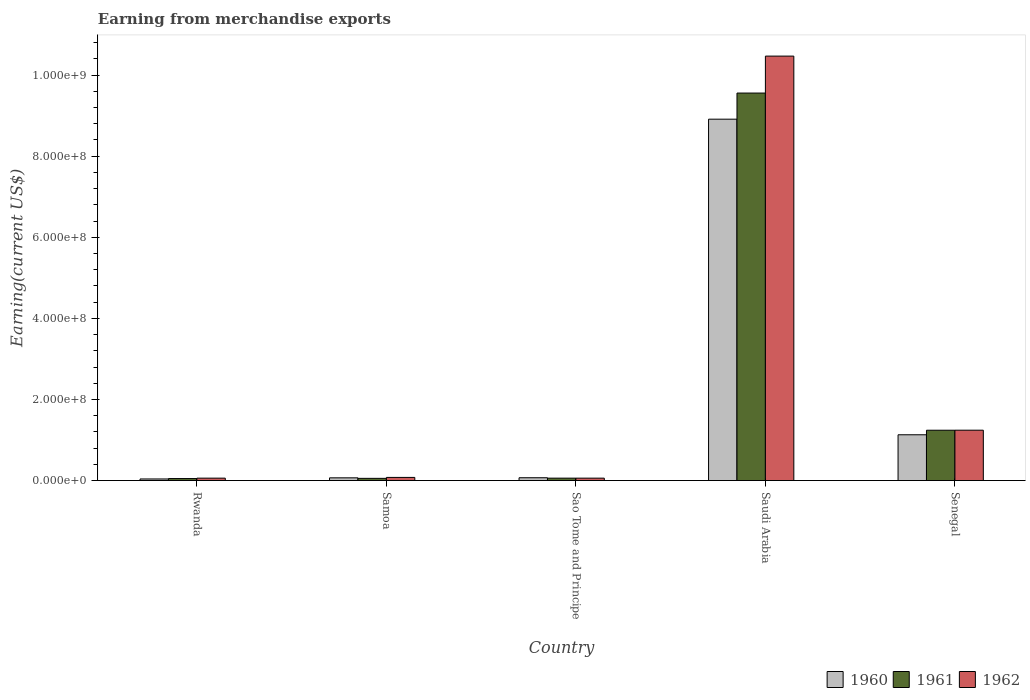How many groups of bars are there?
Ensure brevity in your answer.  5. Are the number of bars on each tick of the X-axis equal?
Provide a succinct answer. Yes. What is the label of the 2nd group of bars from the left?
Provide a succinct answer. Samoa. In how many cases, is the number of bars for a given country not equal to the number of legend labels?
Your answer should be very brief. 0. Across all countries, what is the maximum amount earned from merchandise exports in 1961?
Provide a short and direct response. 9.56e+08. Across all countries, what is the minimum amount earned from merchandise exports in 1960?
Provide a short and direct response. 4.00e+06. In which country was the amount earned from merchandise exports in 1962 maximum?
Keep it short and to the point. Saudi Arabia. In which country was the amount earned from merchandise exports in 1961 minimum?
Give a very brief answer. Rwanda. What is the total amount earned from merchandise exports in 1962 in the graph?
Make the answer very short. 1.19e+09. What is the difference between the amount earned from merchandise exports in 1960 in Rwanda and that in Sao Tome and Principe?
Your response must be concise. -3.00e+06. What is the average amount earned from merchandise exports in 1960 per country?
Keep it short and to the point. 2.04e+08. What is the difference between the amount earned from merchandise exports of/in 1960 and amount earned from merchandise exports of/in 1961 in Senegal?
Offer a very short reply. -1.12e+07. In how many countries, is the amount earned from merchandise exports in 1960 greater than 80000000 US$?
Provide a succinct answer. 2. What is the ratio of the amount earned from merchandise exports in 1962 in Rwanda to that in Saudi Arabia?
Give a very brief answer. 0.01. What is the difference between the highest and the second highest amount earned from merchandise exports in 1962?
Your answer should be compact. 1.04e+09. What is the difference between the highest and the lowest amount earned from merchandise exports in 1960?
Your answer should be compact. 8.87e+08. Is the sum of the amount earned from merchandise exports in 1960 in Rwanda and Sao Tome and Principe greater than the maximum amount earned from merchandise exports in 1962 across all countries?
Make the answer very short. No. What does the 2nd bar from the left in Saudi Arabia represents?
Ensure brevity in your answer.  1961. What does the 1st bar from the right in Saudi Arabia represents?
Your answer should be very brief. 1962. Is it the case that in every country, the sum of the amount earned from merchandise exports in 1961 and amount earned from merchandise exports in 1960 is greater than the amount earned from merchandise exports in 1962?
Offer a very short reply. Yes. How many bars are there?
Ensure brevity in your answer.  15. How many countries are there in the graph?
Keep it short and to the point. 5. What is the difference between two consecutive major ticks on the Y-axis?
Offer a very short reply. 2.00e+08. Are the values on the major ticks of Y-axis written in scientific E-notation?
Provide a succinct answer. Yes. What is the title of the graph?
Offer a terse response. Earning from merchandise exports. What is the label or title of the X-axis?
Provide a short and direct response. Country. What is the label or title of the Y-axis?
Make the answer very short. Earning(current US$). What is the Earning(current US$) in 1960 in Rwanda?
Make the answer very short. 4.00e+06. What is the Earning(current US$) in 1961 in Rwanda?
Your answer should be compact. 5.00e+06. What is the Earning(current US$) in 1962 in Rwanda?
Your answer should be compact. 6.00e+06. What is the Earning(current US$) in 1960 in Samoa?
Give a very brief answer. 6.77e+06. What is the Earning(current US$) in 1961 in Samoa?
Provide a succinct answer. 5.49e+06. What is the Earning(current US$) in 1962 in Samoa?
Make the answer very short. 7.80e+06. What is the Earning(current US$) of 1960 in Sao Tome and Principe?
Offer a terse response. 7.00e+06. What is the Earning(current US$) of 1962 in Sao Tome and Principe?
Ensure brevity in your answer.  6.00e+06. What is the Earning(current US$) of 1960 in Saudi Arabia?
Your answer should be compact. 8.91e+08. What is the Earning(current US$) of 1961 in Saudi Arabia?
Offer a terse response. 9.56e+08. What is the Earning(current US$) of 1962 in Saudi Arabia?
Provide a short and direct response. 1.05e+09. What is the Earning(current US$) in 1960 in Senegal?
Your answer should be compact. 1.13e+08. What is the Earning(current US$) of 1961 in Senegal?
Offer a terse response. 1.24e+08. What is the Earning(current US$) in 1962 in Senegal?
Make the answer very short. 1.24e+08. Across all countries, what is the maximum Earning(current US$) in 1960?
Your response must be concise. 8.91e+08. Across all countries, what is the maximum Earning(current US$) in 1961?
Offer a terse response. 9.56e+08. Across all countries, what is the maximum Earning(current US$) of 1962?
Your answer should be compact. 1.05e+09. What is the total Earning(current US$) in 1960 in the graph?
Offer a terse response. 1.02e+09. What is the total Earning(current US$) in 1961 in the graph?
Make the answer very short. 1.10e+09. What is the total Earning(current US$) of 1962 in the graph?
Your answer should be very brief. 1.19e+09. What is the difference between the Earning(current US$) of 1960 in Rwanda and that in Samoa?
Keep it short and to the point. -2.77e+06. What is the difference between the Earning(current US$) of 1961 in Rwanda and that in Samoa?
Offer a terse response. -4.86e+05. What is the difference between the Earning(current US$) in 1962 in Rwanda and that in Samoa?
Your answer should be very brief. -1.80e+06. What is the difference between the Earning(current US$) of 1960 in Rwanda and that in Sao Tome and Principe?
Make the answer very short. -3.00e+06. What is the difference between the Earning(current US$) in 1961 in Rwanda and that in Sao Tome and Principe?
Provide a short and direct response. -1.00e+06. What is the difference between the Earning(current US$) in 1960 in Rwanda and that in Saudi Arabia?
Your answer should be compact. -8.87e+08. What is the difference between the Earning(current US$) of 1961 in Rwanda and that in Saudi Arabia?
Give a very brief answer. -9.51e+08. What is the difference between the Earning(current US$) of 1962 in Rwanda and that in Saudi Arabia?
Ensure brevity in your answer.  -1.04e+09. What is the difference between the Earning(current US$) of 1960 in Rwanda and that in Senegal?
Keep it short and to the point. -1.09e+08. What is the difference between the Earning(current US$) of 1961 in Rwanda and that in Senegal?
Offer a terse response. -1.19e+08. What is the difference between the Earning(current US$) in 1962 in Rwanda and that in Senegal?
Offer a terse response. -1.18e+08. What is the difference between the Earning(current US$) of 1960 in Samoa and that in Sao Tome and Principe?
Ensure brevity in your answer.  -2.32e+05. What is the difference between the Earning(current US$) in 1961 in Samoa and that in Sao Tome and Principe?
Provide a succinct answer. -5.14e+05. What is the difference between the Earning(current US$) of 1962 in Samoa and that in Sao Tome and Principe?
Your answer should be very brief. 1.80e+06. What is the difference between the Earning(current US$) of 1960 in Samoa and that in Saudi Arabia?
Ensure brevity in your answer.  -8.84e+08. What is the difference between the Earning(current US$) in 1961 in Samoa and that in Saudi Arabia?
Give a very brief answer. -9.50e+08. What is the difference between the Earning(current US$) of 1962 in Samoa and that in Saudi Arabia?
Your answer should be very brief. -1.04e+09. What is the difference between the Earning(current US$) in 1960 in Samoa and that in Senegal?
Your answer should be compact. -1.06e+08. What is the difference between the Earning(current US$) of 1961 in Samoa and that in Senegal?
Your answer should be compact. -1.19e+08. What is the difference between the Earning(current US$) in 1962 in Samoa and that in Senegal?
Give a very brief answer. -1.16e+08. What is the difference between the Earning(current US$) in 1960 in Sao Tome and Principe and that in Saudi Arabia?
Your answer should be very brief. -8.84e+08. What is the difference between the Earning(current US$) in 1961 in Sao Tome and Principe and that in Saudi Arabia?
Your response must be concise. -9.50e+08. What is the difference between the Earning(current US$) of 1962 in Sao Tome and Principe and that in Saudi Arabia?
Your response must be concise. -1.04e+09. What is the difference between the Earning(current US$) in 1960 in Sao Tome and Principe and that in Senegal?
Your response must be concise. -1.06e+08. What is the difference between the Earning(current US$) in 1961 in Sao Tome and Principe and that in Senegal?
Provide a short and direct response. -1.18e+08. What is the difference between the Earning(current US$) of 1962 in Sao Tome and Principe and that in Senegal?
Offer a terse response. -1.18e+08. What is the difference between the Earning(current US$) of 1960 in Saudi Arabia and that in Senegal?
Your answer should be very brief. 7.78e+08. What is the difference between the Earning(current US$) of 1961 in Saudi Arabia and that in Senegal?
Your answer should be very brief. 8.31e+08. What is the difference between the Earning(current US$) in 1962 in Saudi Arabia and that in Senegal?
Offer a terse response. 9.22e+08. What is the difference between the Earning(current US$) of 1960 in Rwanda and the Earning(current US$) of 1961 in Samoa?
Your response must be concise. -1.49e+06. What is the difference between the Earning(current US$) of 1960 in Rwanda and the Earning(current US$) of 1962 in Samoa?
Your answer should be compact. -3.80e+06. What is the difference between the Earning(current US$) in 1961 in Rwanda and the Earning(current US$) in 1962 in Samoa?
Ensure brevity in your answer.  -2.80e+06. What is the difference between the Earning(current US$) in 1960 in Rwanda and the Earning(current US$) in 1962 in Sao Tome and Principe?
Offer a very short reply. -2.00e+06. What is the difference between the Earning(current US$) of 1961 in Rwanda and the Earning(current US$) of 1962 in Sao Tome and Principe?
Your answer should be very brief. -1.00e+06. What is the difference between the Earning(current US$) in 1960 in Rwanda and the Earning(current US$) in 1961 in Saudi Arabia?
Offer a very short reply. -9.52e+08. What is the difference between the Earning(current US$) in 1960 in Rwanda and the Earning(current US$) in 1962 in Saudi Arabia?
Give a very brief answer. -1.04e+09. What is the difference between the Earning(current US$) of 1961 in Rwanda and the Earning(current US$) of 1962 in Saudi Arabia?
Provide a short and direct response. -1.04e+09. What is the difference between the Earning(current US$) of 1960 in Rwanda and the Earning(current US$) of 1961 in Senegal?
Keep it short and to the point. -1.20e+08. What is the difference between the Earning(current US$) in 1960 in Rwanda and the Earning(current US$) in 1962 in Senegal?
Keep it short and to the point. -1.20e+08. What is the difference between the Earning(current US$) of 1961 in Rwanda and the Earning(current US$) of 1962 in Senegal?
Make the answer very short. -1.19e+08. What is the difference between the Earning(current US$) in 1960 in Samoa and the Earning(current US$) in 1961 in Sao Tome and Principe?
Your response must be concise. 7.68e+05. What is the difference between the Earning(current US$) of 1960 in Samoa and the Earning(current US$) of 1962 in Sao Tome and Principe?
Ensure brevity in your answer.  7.68e+05. What is the difference between the Earning(current US$) in 1961 in Samoa and the Earning(current US$) in 1962 in Sao Tome and Principe?
Your response must be concise. -5.14e+05. What is the difference between the Earning(current US$) of 1960 in Samoa and the Earning(current US$) of 1961 in Saudi Arabia?
Keep it short and to the point. -9.49e+08. What is the difference between the Earning(current US$) of 1960 in Samoa and the Earning(current US$) of 1962 in Saudi Arabia?
Your response must be concise. -1.04e+09. What is the difference between the Earning(current US$) of 1961 in Samoa and the Earning(current US$) of 1962 in Saudi Arabia?
Offer a very short reply. -1.04e+09. What is the difference between the Earning(current US$) of 1960 in Samoa and the Earning(current US$) of 1961 in Senegal?
Ensure brevity in your answer.  -1.17e+08. What is the difference between the Earning(current US$) of 1960 in Samoa and the Earning(current US$) of 1962 in Senegal?
Your answer should be compact. -1.17e+08. What is the difference between the Earning(current US$) in 1961 in Samoa and the Earning(current US$) in 1962 in Senegal?
Ensure brevity in your answer.  -1.19e+08. What is the difference between the Earning(current US$) of 1960 in Sao Tome and Principe and the Earning(current US$) of 1961 in Saudi Arabia?
Make the answer very short. -9.49e+08. What is the difference between the Earning(current US$) of 1960 in Sao Tome and Principe and the Earning(current US$) of 1962 in Saudi Arabia?
Give a very brief answer. -1.04e+09. What is the difference between the Earning(current US$) in 1961 in Sao Tome and Principe and the Earning(current US$) in 1962 in Saudi Arabia?
Provide a short and direct response. -1.04e+09. What is the difference between the Earning(current US$) in 1960 in Sao Tome and Principe and the Earning(current US$) in 1961 in Senegal?
Your answer should be compact. -1.17e+08. What is the difference between the Earning(current US$) in 1960 in Sao Tome and Principe and the Earning(current US$) in 1962 in Senegal?
Provide a succinct answer. -1.17e+08. What is the difference between the Earning(current US$) of 1961 in Sao Tome and Principe and the Earning(current US$) of 1962 in Senegal?
Make the answer very short. -1.18e+08. What is the difference between the Earning(current US$) of 1960 in Saudi Arabia and the Earning(current US$) of 1961 in Senegal?
Offer a very short reply. 7.67e+08. What is the difference between the Earning(current US$) of 1960 in Saudi Arabia and the Earning(current US$) of 1962 in Senegal?
Provide a succinct answer. 7.67e+08. What is the difference between the Earning(current US$) in 1961 in Saudi Arabia and the Earning(current US$) in 1962 in Senegal?
Offer a terse response. 8.31e+08. What is the average Earning(current US$) in 1960 per country?
Offer a very short reply. 2.04e+08. What is the average Earning(current US$) in 1961 per country?
Provide a short and direct response. 2.19e+08. What is the average Earning(current US$) in 1962 per country?
Keep it short and to the point. 2.38e+08. What is the difference between the Earning(current US$) of 1960 and Earning(current US$) of 1961 in Rwanda?
Make the answer very short. -1.00e+06. What is the difference between the Earning(current US$) in 1960 and Earning(current US$) in 1962 in Rwanda?
Make the answer very short. -2.00e+06. What is the difference between the Earning(current US$) of 1960 and Earning(current US$) of 1961 in Samoa?
Offer a terse response. 1.28e+06. What is the difference between the Earning(current US$) of 1960 and Earning(current US$) of 1962 in Samoa?
Provide a short and direct response. -1.04e+06. What is the difference between the Earning(current US$) of 1961 and Earning(current US$) of 1962 in Samoa?
Your answer should be very brief. -2.32e+06. What is the difference between the Earning(current US$) of 1960 and Earning(current US$) of 1962 in Sao Tome and Principe?
Offer a very short reply. 1.00e+06. What is the difference between the Earning(current US$) in 1960 and Earning(current US$) in 1961 in Saudi Arabia?
Your answer should be compact. -6.44e+07. What is the difference between the Earning(current US$) of 1960 and Earning(current US$) of 1962 in Saudi Arabia?
Your response must be concise. -1.56e+08. What is the difference between the Earning(current US$) in 1961 and Earning(current US$) in 1962 in Saudi Arabia?
Provide a succinct answer. -9.11e+07. What is the difference between the Earning(current US$) in 1960 and Earning(current US$) in 1961 in Senegal?
Offer a terse response. -1.12e+07. What is the difference between the Earning(current US$) of 1960 and Earning(current US$) of 1962 in Senegal?
Make the answer very short. -1.13e+07. What is the difference between the Earning(current US$) in 1961 and Earning(current US$) in 1962 in Senegal?
Provide a succinct answer. -8.10e+04. What is the ratio of the Earning(current US$) of 1960 in Rwanda to that in Samoa?
Keep it short and to the point. 0.59. What is the ratio of the Earning(current US$) of 1961 in Rwanda to that in Samoa?
Ensure brevity in your answer.  0.91. What is the ratio of the Earning(current US$) of 1962 in Rwanda to that in Samoa?
Keep it short and to the point. 0.77. What is the ratio of the Earning(current US$) in 1960 in Rwanda to that in Sao Tome and Principe?
Ensure brevity in your answer.  0.57. What is the ratio of the Earning(current US$) in 1960 in Rwanda to that in Saudi Arabia?
Offer a terse response. 0. What is the ratio of the Earning(current US$) in 1961 in Rwanda to that in Saudi Arabia?
Make the answer very short. 0.01. What is the ratio of the Earning(current US$) in 1962 in Rwanda to that in Saudi Arabia?
Your answer should be compact. 0.01. What is the ratio of the Earning(current US$) in 1960 in Rwanda to that in Senegal?
Keep it short and to the point. 0.04. What is the ratio of the Earning(current US$) of 1961 in Rwanda to that in Senegal?
Ensure brevity in your answer.  0.04. What is the ratio of the Earning(current US$) of 1962 in Rwanda to that in Senegal?
Provide a short and direct response. 0.05. What is the ratio of the Earning(current US$) in 1960 in Samoa to that in Sao Tome and Principe?
Provide a short and direct response. 0.97. What is the ratio of the Earning(current US$) of 1961 in Samoa to that in Sao Tome and Principe?
Make the answer very short. 0.91. What is the ratio of the Earning(current US$) in 1962 in Samoa to that in Sao Tome and Principe?
Your answer should be very brief. 1.3. What is the ratio of the Earning(current US$) in 1960 in Samoa to that in Saudi Arabia?
Provide a short and direct response. 0.01. What is the ratio of the Earning(current US$) of 1961 in Samoa to that in Saudi Arabia?
Give a very brief answer. 0.01. What is the ratio of the Earning(current US$) of 1962 in Samoa to that in Saudi Arabia?
Your answer should be compact. 0.01. What is the ratio of the Earning(current US$) in 1960 in Samoa to that in Senegal?
Keep it short and to the point. 0.06. What is the ratio of the Earning(current US$) of 1961 in Samoa to that in Senegal?
Offer a very short reply. 0.04. What is the ratio of the Earning(current US$) of 1962 in Samoa to that in Senegal?
Provide a succinct answer. 0.06. What is the ratio of the Earning(current US$) of 1960 in Sao Tome and Principe to that in Saudi Arabia?
Your response must be concise. 0.01. What is the ratio of the Earning(current US$) in 1961 in Sao Tome and Principe to that in Saudi Arabia?
Your answer should be very brief. 0.01. What is the ratio of the Earning(current US$) in 1962 in Sao Tome and Principe to that in Saudi Arabia?
Your answer should be compact. 0.01. What is the ratio of the Earning(current US$) in 1960 in Sao Tome and Principe to that in Senegal?
Ensure brevity in your answer.  0.06. What is the ratio of the Earning(current US$) in 1961 in Sao Tome and Principe to that in Senegal?
Offer a terse response. 0.05. What is the ratio of the Earning(current US$) in 1962 in Sao Tome and Principe to that in Senegal?
Your response must be concise. 0.05. What is the ratio of the Earning(current US$) of 1960 in Saudi Arabia to that in Senegal?
Keep it short and to the point. 7.89. What is the ratio of the Earning(current US$) of 1961 in Saudi Arabia to that in Senegal?
Your response must be concise. 7.7. What is the ratio of the Earning(current US$) of 1962 in Saudi Arabia to that in Senegal?
Provide a succinct answer. 8.42. What is the difference between the highest and the second highest Earning(current US$) in 1960?
Keep it short and to the point. 7.78e+08. What is the difference between the highest and the second highest Earning(current US$) in 1961?
Your response must be concise. 8.31e+08. What is the difference between the highest and the second highest Earning(current US$) of 1962?
Ensure brevity in your answer.  9.22e+08. What is the difference between the highest and the lowest Earning(current US$) of 1960?
Your response must be concise. 8.87e+08. What is the difference between the highest and the lowest Earning(current US$) of 1961?
Keep it short and to the point. 9.51e+08. What is the difference between the highest and the lowest Earning(current US$) in 1962?
Provide a succinct answer. 1.04e+09. 